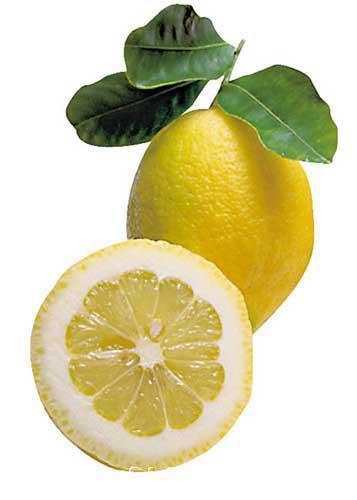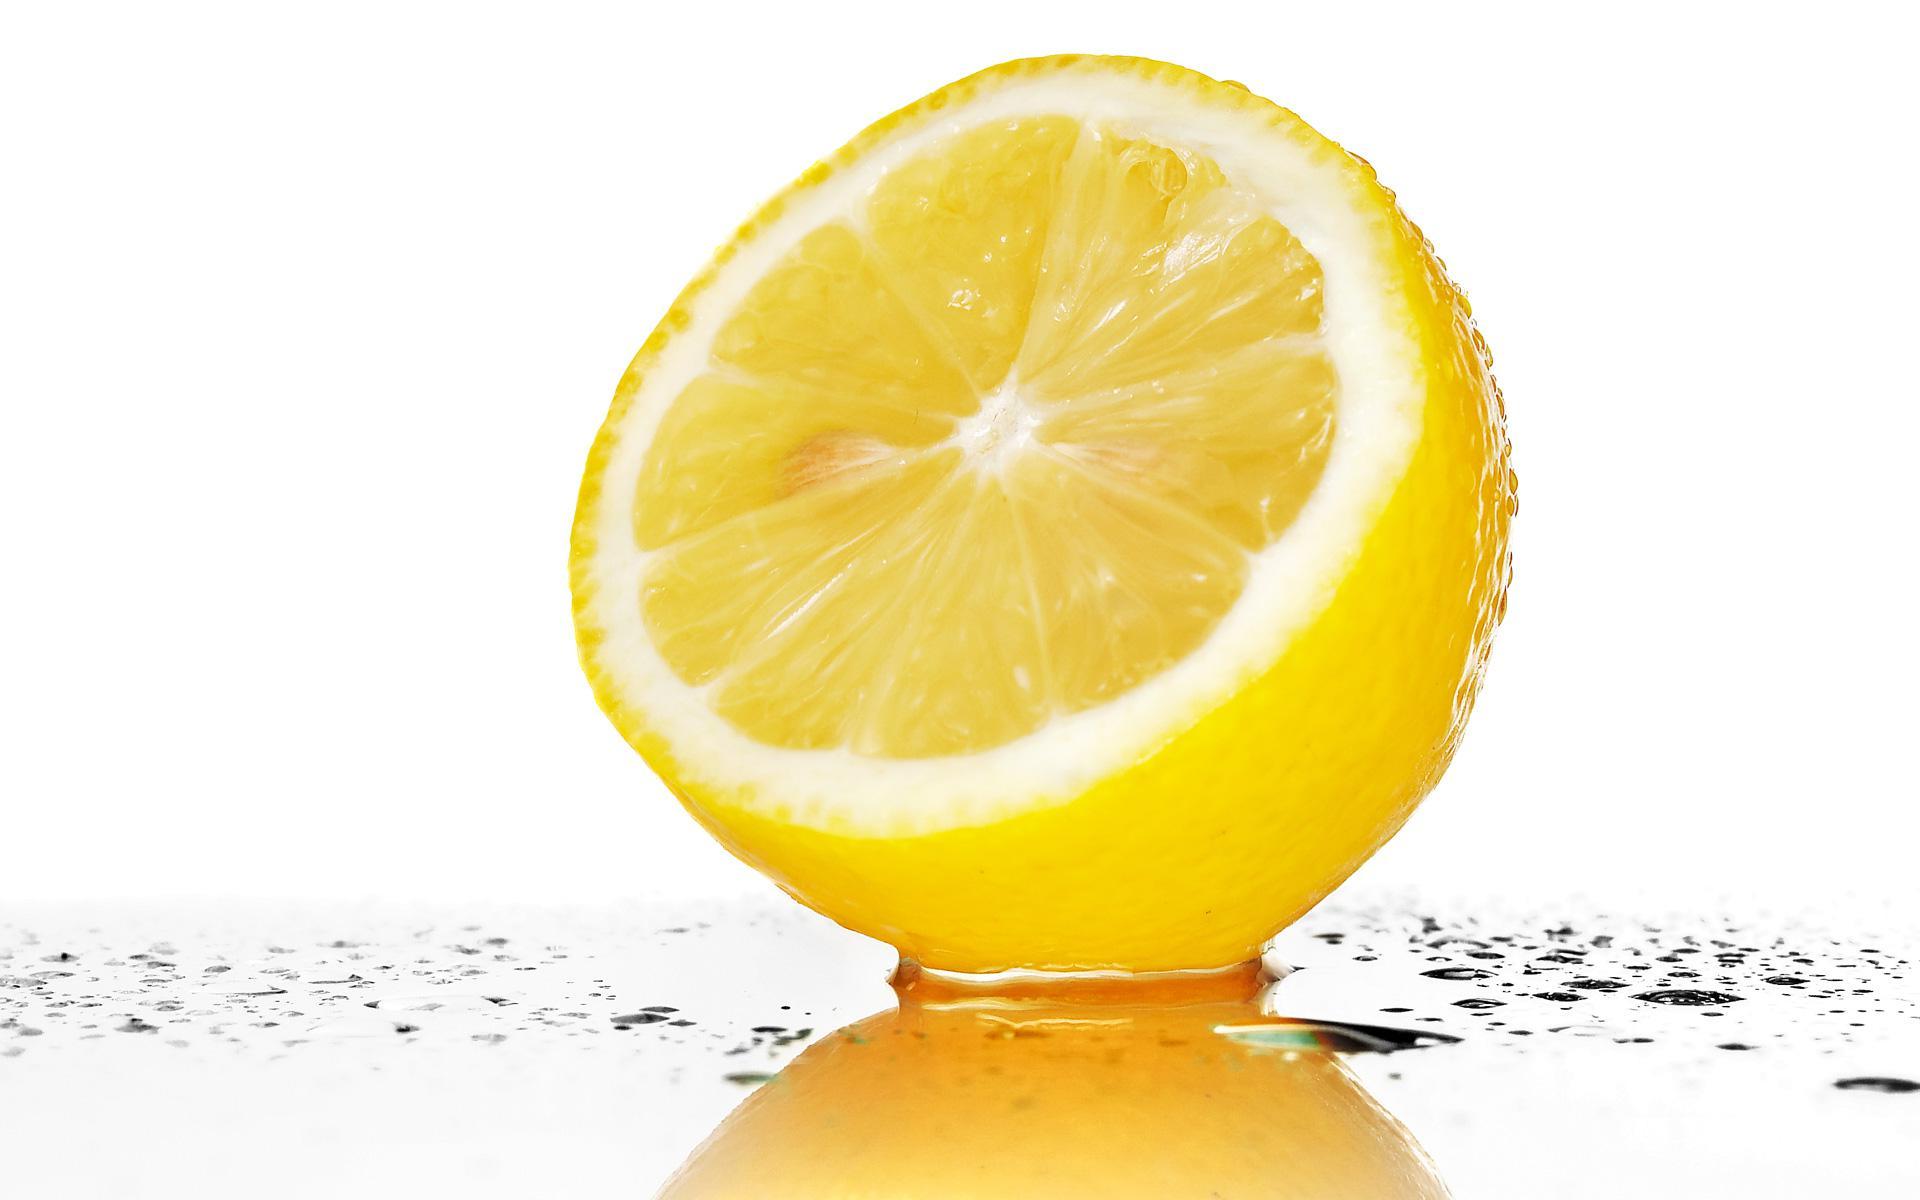The first image is the image on the left, the second image is the image on the right. For the images displayed, is the sentence "No leaves are visible in the pictures on the right." factually correct? Answer yes or no. Yes. 